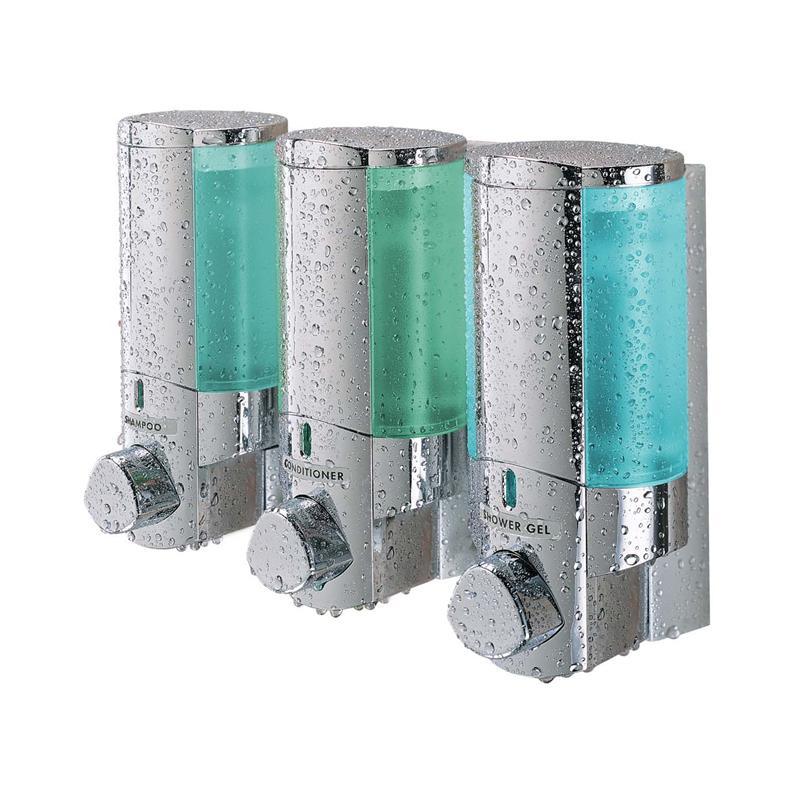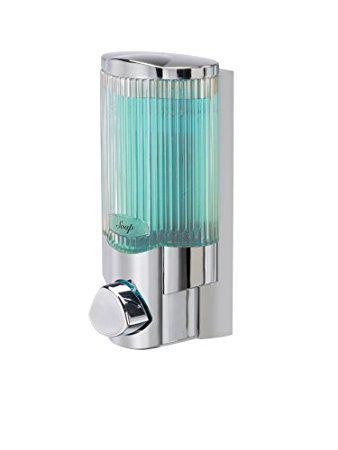The first image is the image on the left, the second image is the image on the right. Given the left and right images, does the statement "There is liquid filling at least five dispensers." hold true? Answer yes or no. No. The first image is the image on the left, the second image is the image on the right. Given the left and right images, does the statement "An image shows a trio of cylindrical dispensers that mount together, and one dispenses a white creamy-looking substance." hold true? Answer yes or no. No. 